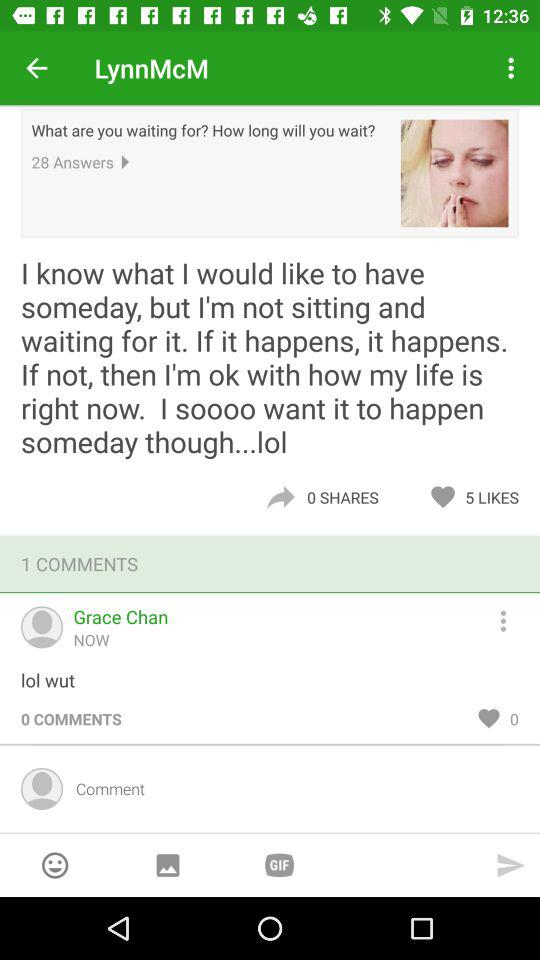How many more likes does the post have than shares?
Answer the question using a single word or phrase. 5 